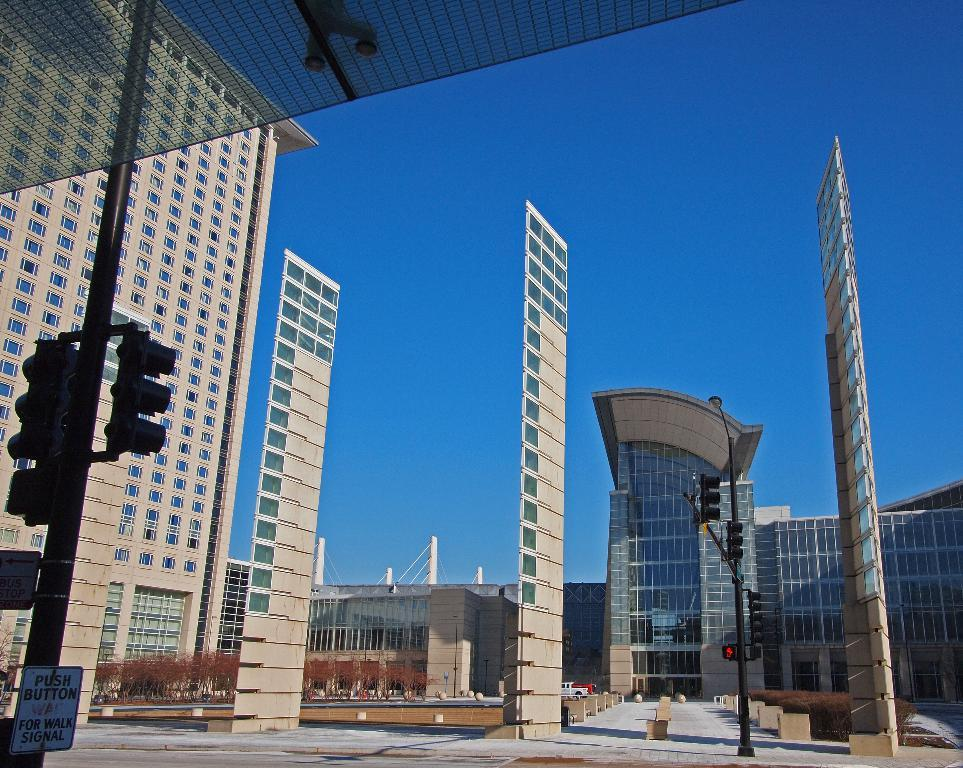What is the main feature in the center of the image? There is a sky in the center of the image. What type of structures can be seen in the image? There are buildings in the image. What is the purpose of the sign board in the image? The purpose of the sign board in the image is to provide information or directions. How do the traffic lights function in the image? The traffic lights in the image regulate the flow of traffic. What are the poles used for in the image? The poles in the image are likely used to support traffic lights, sign boards, or other infrastructure. What can be seen in the windows of the buildings in the image? The contents of the windows in the image cannot be determined from the provided facts. What type of vegetation is present in the image? Trees are present in the image. What types of vehicles can be seen in the image? Vehicles are visible in the image, but their specific types cannot be determined from the provided facts. What are the other objects present in the image? There are a few other objects in the image, but their specific nature cannot be determined from the provided facts. Where is the kitten playing with a cannon in the image? There is no kitten or cannon present in the image. What type of bread is being sold at the bakery in the image? There is no bakery or bread present in the image. 